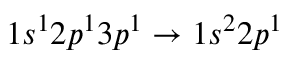<formula> <loc_0><loc_0><loc_500><loc_500>1 s ^ { 1 } 2 p ^ { 1 } 3 p ^ { 1 } \rightarrow 1 s ^ { 2 } 2 p ^ { 1 }</formula> 